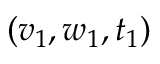<formula> <loc_0><loc_0><loc_500><loc_500>( v _ { 1 } , w _ { 1 } , t _ { 1 } )</formula> 